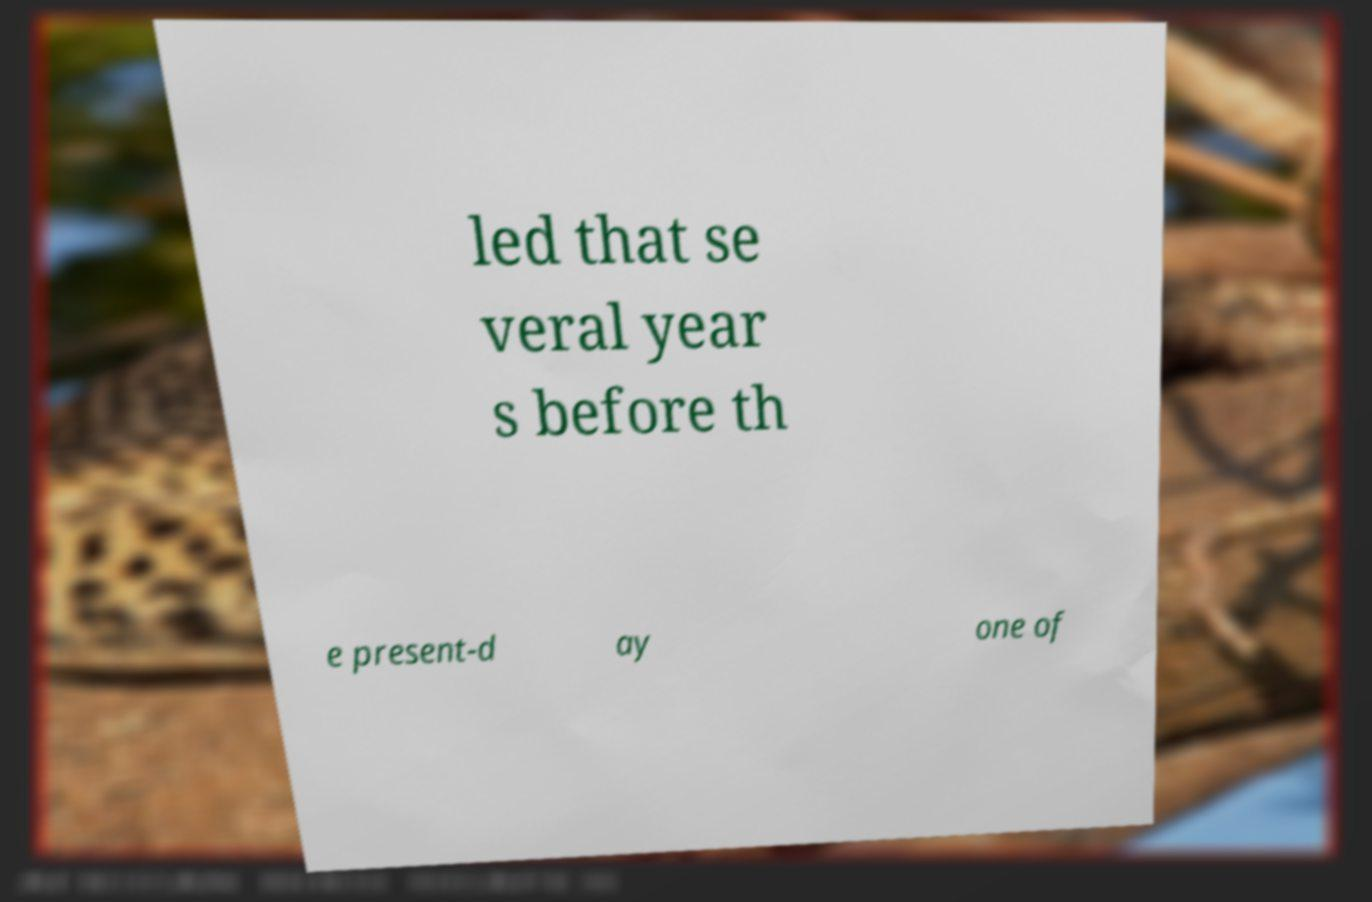Could you assist in decoding the text presented in this image and type it out clearly? led that se veral year s before th e present-d ay one of 